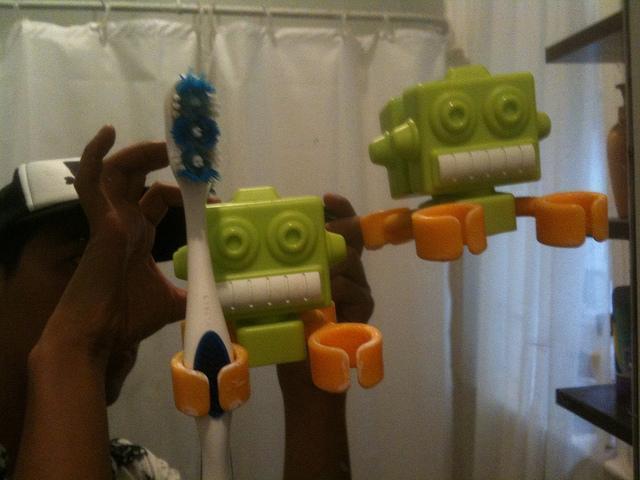How many "teeth" does each robot have?
Give a very brief answer. 6. How many toothbrushes are present?
Give a very brief answer. 1. 